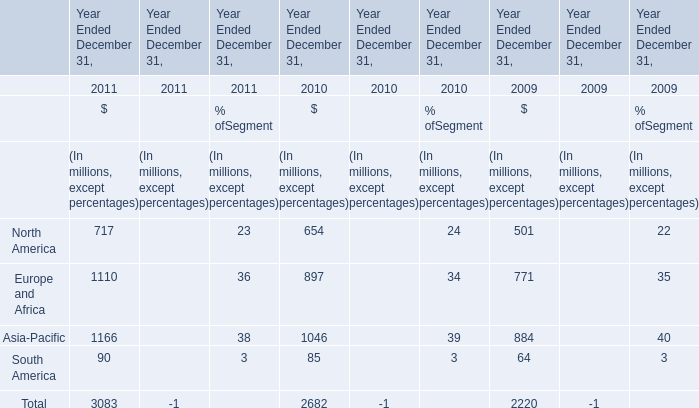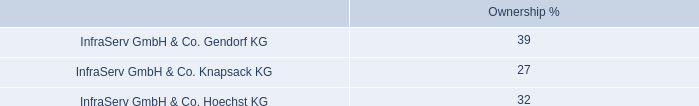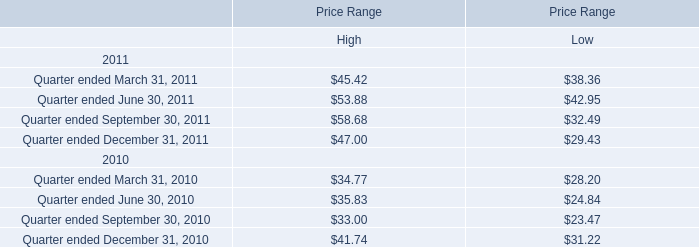what was the percentage growth in the cash dividends from 2010 to 2011 
Computations: ((78 - 71) / 71)
Answer: 0.09859. 